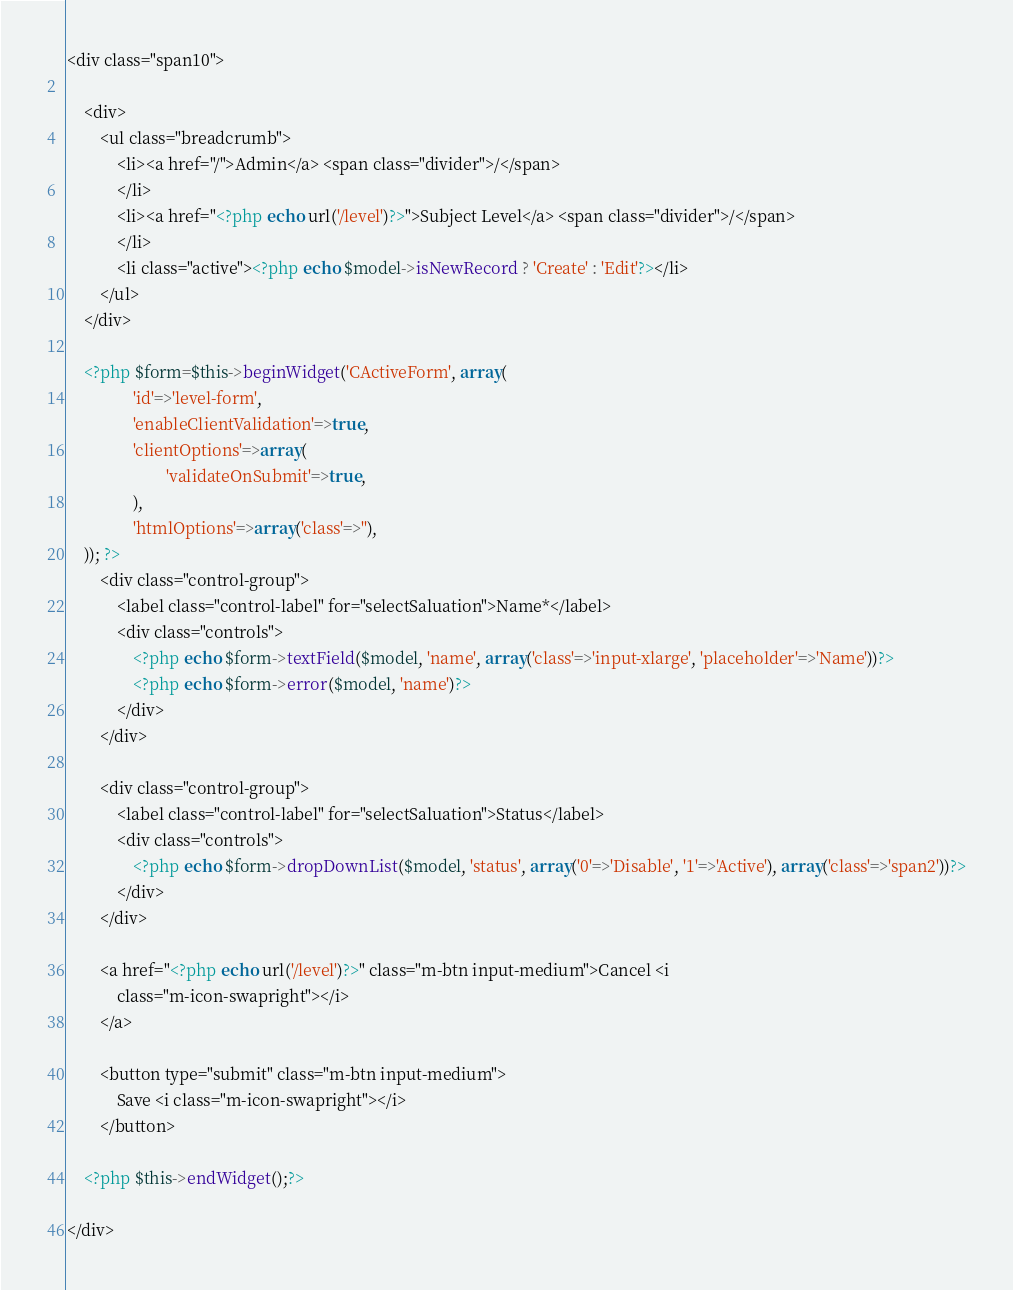<code> <loc_0><loc_0><loc_500><loc_500><_PHP_><div class="span10">

	<div>
		<ul class="breadcrumb">
			<li><a href="/">Admin</a> <span class="divider">/</span>
			</li>
			<li><a href="<?php echo url('/level')?>">Subject Level</a> <span class="divider">/</span>
			</li>
			<li class="active"><?php echo $model->isNewRecord ? 'Create' : 'Edit'?></li>
		</ul>
	</div>
	
	<?php $form=$this->beginWidget('CActiveForm', array(
				'id'=>'level-form',
				'enableClientValidation'=>true,
				'clientOptions'=>array(
						'validateOnSubmit'=>true,
				),
				'htmlOptions'=>array('class'=>''),
	)); ?>
		<div class="control-group">
            <label class="control-label" for="selectSaluation">Name*</label>
            <div class="controls">
            	<?php echo $form->textField($model, 'name', array('class'=>'input-xlarge', 'placeholder'=>'Name'))?>
            	<?php echo $form->error($model, 'name')?>
            </div>
        </div>
	
		<div class="control-group">
			<label class="control-label" for="selectSaluation">Status</label>
			<div class="controls">
				<?php echo $form->dropDownList($model, 'status', array('0'=>'Disable', '1'=>'Active'), array('class'=>'span2'))?>
			</div>
		</div>

		<a href="<?php echo url('/level')?>" class="m-btn input-medium">Cancel <i
			class="m-icon-swapright"></i>
		</a>
	
		<button type="submit" class="m-btn input-medium">
			Save <i class="m-icon-swapright"></i>
		</button>
		
	<?php $this->endWidget();?>

</div></code> 